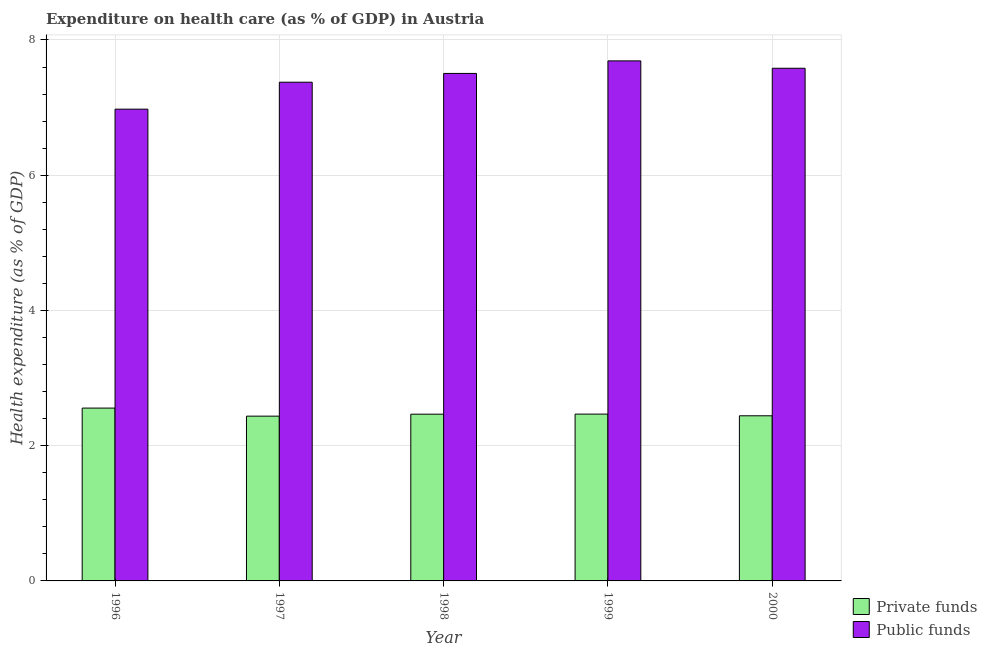How many different coloured bars are there?
Ensure brevity in your answer.  2. How many groups of bars are there?
Ensure brevity in your answer.  5. How many bars are there on the 1st tick from the right?
Ensure brevity in your answer.  2. What is the label of the 3rd group of bars from the left?
Keep it short and to the point. 1998. What is the amount of private funds spent in healthcare in 1997?
Ensure brevity in your answer.  2.44. Across all years, what is the maximum amount of private funds spent in healthcare?
Make the answer very short. 2.56. Across all years, what is the minimum amount of public funds spent in healthcare?
Provide a short and direct response. 6.98. What is the total amount of public funds spent in healthcare in the graph?
Provide a succinct answer. 37.13. What is the difference between the amount of public funds spent in healthcare in 1996 and that in 1997?
Your response must be concise. -0.4. What is the difference between the amount of public funds spent in healthcare in 1997 and the amount of private funds spent in healthcare in 1999?
Your response must be concise. -0.32. What is the average amount of public funds spent in healthcare per year?
Ensure brevity in your answer.  7.43. In the year 1997, what is the difference between the amount of public funds spent in healthcare and amount of private funds spent in healthcare?
Your response must be concise. 0. In how many years, is the amount of public funds spent in healthcare greater than 0.4 %?
Offer a terse response. 5. What is the ratio of the amount of private funds spent in healthcare in 1998 to that in 1999?
Ensure brevity in your answer.  1. Is the amount of public funds spent in healthcare in 1996 less than that in 1998?
Offer a terse response. Yes. Is the difference between the amount of public funds spent in healthcare in 1996 and 1997 greater than the difference between the amount of private funds spent in healthcare in 1996 and 1997?
Offer a terse response. No. What is the difference between the highest and the second highest amount of public funds spent in healthcare?
Provide a succinct answer. 0.11. What is the difference between the highest and the lowest amount of private funds spent in healthcare?
Offer a terse response. 0.12. What does the 2nd bar from the left in 1996 represents?
Your answer should be compact. Public funds. What does the 2nd bar from the right in 1998 represents?
Your response must be concise. Private funds. Are all the bars in the graph horizontal?
Your answer should be very brief. No. What is the difference between two consecutive major ticks on the Y-axis?
Make the answer very short. 2. Are the values on the major ticks of Y-axis written in scientific E-notation?
Offer a very short reply. No. Does the graph contain grids?
Give a very brief answer. Yes. What is the title of the graph?
Ensure brevity in your answer.  Expenditure on health care (as % of GDP) in Austria. What is the label or title of the X-axis?
Provide a short and direct response. Year. What is the label or title of the Y-axis?
Your response must be concise. Health expenditure (as % of GDP). What is the Health expenditure (as % of GDP) of Private funds in 1996?
Your answer should be very brief. 2.56. What is the Health expenditure (as % of GDP) in Public funds in 1996?
Your answer should be very brief. 6.98. What is the Health expenditure (as % of GDP) of Private funds in 1997?
Give a very brief answer. 2.44. What is the Health expenditure (as % of GDP) of Public funds in 1997?
Ensure brevity in your answer.  7.38. What is the Health expenditure (as % of GDP) in Private funds in 1998?
Offer a very short reply. 2.47. What is the Health expenditure (as % of GDP) of Public funds in 1998?
Provide a short and direct response. 7.51. What is the Health expenditure (as % of GDP) of Private funds in 1999?
Keep it short and to the point. 2.47. What is the Health expenditure (as % of GDP) in Public funds in 1999?
Offer a very short reply. 7.69. What is the Health expenditure (as % of GDP) in Private funds in 2000?
Give a very brief answer. 2.44. What is the Health expenditure (as % of GDP) of Public funds in 2000?
Provide a short and direct response. 7.58. Across all years, what is the maximum Health expenditure (as % of GDP) in Private funds?
Give a very brief answer. 2.56. Across all years, what is the maximum Health expenditure (as % of GDP) in Public funds?
Offer a terse response. 7.69. Across all years, what is the minimum Health expenditure (as % of GDP) in Private funds?
Your answer should be compact. 2.44. Across all years, what is the minimum Health expenditure (as % of GDP) of Public funds?
Your answer should be compact. 6.98. What is the total Health expenditure (as % of GDP) in Private funds in the graph?
Make the answer very short. 12.37. What is the total Health expenditure (as % of GDP) in Public funds in the graph?
Provide a succinct answer. 37.13. What is the difference between the Health expenditure (as % of GDP) in Private funds in 1996 and that in 1997?
Keep it short and to the point. 0.12. What is the difference between the Health expenditure (as % of GDP) of Public funds in 1996 and that in 1997?
Offer a terse response. -0.4. What is the difference between the Health expenditure (as % of GDP) in Private funds in 1996 and that in 1998?
Ensure brevity in your answer.  0.09. What is the difference between the Health expenditure (as % of GDP) in Public funds in 1996 and that in 1998?
Your answer should be very brief. -0.53. What is the difference between the Health expenditure (as % of GDP) in Private funds in 1996 and that in 1999?
Make the answer very short. 0.09. What is the difference between the Health expenditure (as % of GDP) of Public funds in 1996 and that in 1999?
Make the answer very short. -0.71. What is the difference between the Health expenditure (as % of GDP) of Private funds in 1996 and that in 2000?
Provide a succinct answer. 0.11. What is the difference between the Health expenditure (as % of GDP) in Public funds in 1996 and that in 2000?
Your answer should be very brief. -0.6. What is the difference between the Health expenditure (as % of GDP) of Private funds in 1997 and that in 1998?
Offer a terse response. -0.03. What is the difference between the Health expenditure (as % of GDP) of Public funds in 1997 and that in 1998?
Keep it short and to the point. -0.13. What is the difference between the Health expenditure (as % of GDP) in Private funds in 1997 and that in 1999?
Give a very brief answer. -0.03. What is the difference between the Health expenditure (as % of GDP) of Public funds in 1997 and that in 1999?
Offer a very short reply. -0.32. What is the difference between the Health expenditure (as % of GDP) of Private funds in 1997 and that in 2000?
Your answer should be compact. -0.01. What is the difference between the Health expenditure (as % of GDP) in Public funds in 1997 and that in 2000?
Provide a succinct answer. -0.21. What is the difference between the Health expenditure (as % of GDP) in Private funds in 1998 and that in 1999?
Make the answer very short. -0. What is the difference between the Health expenditure (as % of GDP) in Public funds in 1998 and that in 1999?
Keep it short and to the point. -0.19. What is the difference between the Health expenditure (as % of GDP) in Private funds in 1998 and that in 2000?
Offer a very short reply. 0.02. What is the difference between the Health expenditure (as % of GDP) of Public funds in 1998 and that in 2000?
Your response must be concise. -0.08. What is the difference between the Health expenditure (as % of GDP) of Private funds in 1999 and that in 2000?
Ensure brevity in your answer.  0.02. What is the difference between the Health expenditure (as % of GDP) of Public funds in 1999 and that in 2000?
Give a very brief answer. 0.11. What is the difference between the Health expenditure (as % of GDP) in Private funds in 1996 and the Health expenditure (as % of GDP) in Public funds in 1997?
Provide a short and direct response. -4.82. What is the difference between the Health expenditure (as % of GDP) of Private funds in 1996 and the Health expenditure (as % of GDP) of Public funds in 1998?
Provide a short and direct response. -4.95. What is the difference between the Health expenditure (as % of GDP) in Private funds in 1996 and the Health expenditure (as % of GDP) in Public funds in 1999?
Your answer should be compact. -5.13. What is the difference between the Health expenditure (as % of GDP) of Private funds in 1996 and the Health expenditure (as % of GDP) of Public funds in 2000?
Provide a short and direct response. -5.03. What is the difference between the Health expenditure (as % of GDP) in Private funds in 1997 and the Health expenditure (as % of GDP) in Public funds in 1998?
Your answer should be very brief. -5.07. What is the difference between the Health expenditure (as % of GDP) of Private funds in 1997 and the Health expenditure (as % of GDP) of Public funds in 1999?
Offer a terse response. -5.25. What is the difference between the Health expenditure (as % of GDP) of Private funds in 1997 and the Health expenditure (as % of GDP) of Public funds in 2000?
Your answer should be compact. -5.15. What is the difference between the Health expenditure (as % of GDP) of Private funds in 1998 and the Health expenditure (as % of GDP) of Public funds in 1999?
Provide a short and direct response. -5.23. What is the difference between the Health expenditure (as % of GDP) in Private funds in 1998 and the Health expenditure (as % of GDP) in Public funds in 2000?
Ensure brevity in your answer.  -5.12. What is the difference between the Health expenditure (as % of GDP) of Private funds in 1999 and the Health expenditure (as % of GDP) of Public funds in 2000?
Make the answer very short. -5.11. What is the average Health expenditure (as % of GDP) of Private funds per year?
Offer a very short reply. 2.47. What is the average Health expenditure (as % of GDP) in Public funds per year?
Provide a short and direct response. 7.43. In the year 1996, what is the difference between the Health expenditure (as % of GDP) of Private funds and Health expenditure (as % of GDP) of Public funds?
Make the answer very short. -4.42. In the year 1997, what is the difference between the Health expenditure (as % of GDP) in Private funds and Health expenditure (as % of GDP) in Public funds?
Your answer should be compact. -4.94. In the year 1998, what is the difference between the Health expenditure (as % of GDP) of Private funds and Health expenditure (as % of GDP) of Public funds?
Give a very brief answer. -5.04. In the year 1999, what is the difference between the Health expenditure (as % of GDP) of Private funds and Health expenditure (as % of GDP) of Public funds?
Ensure brevity in your answer.  -5.22. In the year 2000, what is the difference between the Health expenditure (as % of GDP) in Private funds and Health expenditure (as % of GDP) in Public funds?
Keep it short and to the point. -5.14. What is the ratio of the Health expenditure (as % of GDP) of Private funds in 1996 to that in 1997?
Your response must be concise. 1.05. What is the ratio of the Health expenditure (as % of GDP) in Public funds in 1996 to that in 1997?
Give a very brief answer. 0.95. What is the ratio of the Health expenditure (as % of GDP) of Private funds in 1996 to that in 1998?
Make the answer very short. 1.04. What is the ratio of the Health expenditure (as % of GDP) in Public funds in 1996 to that in 1998?
Keep it short and to the point. 0.93. What is the ratio of the Health expenditure (as % of GDP) of Private funds in 1996 to that in 1999?
Your answer should be very brief. 1.04. What is the ratio of the Health expenditure (as % of GDP) in Public funds in 1996 to that in 1999?
Provide a succinct answer. 0.91. What is the ratio of the Health expenditure (as % of GDP) of Private funds in 1996 to that in 2000?
Provide a succinct answer. 1.05. What is the ratio of the Health expenditure (as % of GDP) of Public funds in 1996 to that in 2000?
Give a very brief answer. 0.92. What is the ratio of the Health expenditure (as % of GDP) of Public funds in 1997 to that in 1998?
Offer a very short reply. 0.98. What is the ratio of the Health expenditure (as % of GDP) of Private funds in 1997 to that in 1999?
Offer a terse response. 0.99. What is the ratio of the Health expenditure (as % of GDP) of Public funds in 1997 to that in 1999?
Your response must be concise. 0.96. What is the ratio of the Health expenditure (as % of GDP) in Private funds in 1997 to that in 2000?
Provide a succinct answer. 1. What is the ratio of the Health expenditure (as % of GDP) of Public funds in 1997 to that in 2000?
Make the answer very short. 0.97. What is the ratio of the Health expenditure (as % of GDP) in Private funds in 1998 to that in 1999?
Keep it short and to the point. 1. What is the ratio of the Health expenditure (as % of GDP) in Public funds in 1998 to that in 1999?
Offer a very short reply. 0.98. What is the ratio of the Health expenditure (as % of GDP) of Private funds in 1998 to that in 2000?
Provide a short and direct response. 1.01. What is the ratio of the Health expenditure (as % of GDP) in Public funds in 1998 to that in 2000?
Provide a short and direct response. 0.99. What is the ratio of the Health expenditure (as % of GDP) in Private funds in 1999 to that in 2000?
Make the answer very short. 1.01. What is the ratio of the Health expenditure (as % of GDP) of Public funds in 1999 to that in 2000?
Offer a terse response. 1.01. What is the difference between the highest and the second highest Health expenditure (as % of GDP) in Private funds?
Provide a succinct answer. 0.09. What is the difference between the highest and the second highest Health expenditure (as % of GDP) in Public funds?
Ensure brevity in your answer.  0.11. What is the difference between the highest and the lowest Health expenditure (as % of GDP) in Private funds?
Your response must be concise. 0.12. What is the difference between the highest and the lowest Health expenditure (as % of GDP) of Public funds?
Make the answer very short. 0.71. 